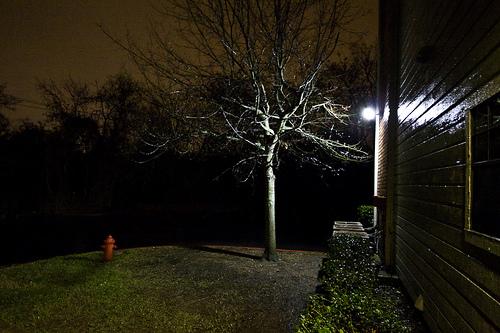Does the tree have foliage?
Be succinct. No. Is there a person in the photo?
Short answer required. No. What is the color of the tree?
Give a very brief answer. Brown. What is around the small tree?
Keep it brief. Dirt. Is the fire hydrant smaller than the tree?
Give a very brief answer. Yes. Is there a sidewalk near the fire hydrant?
Keep it brief. No. Is this vehicle commonly owned?
Quick response, please. No. 